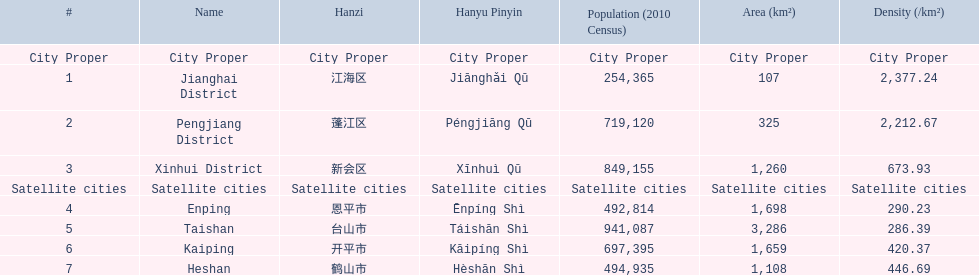What city propers are listed? Jianghai District, Pengjiang District, Xinhui District. Which hast he smallest area in km2? Jianghai District. 